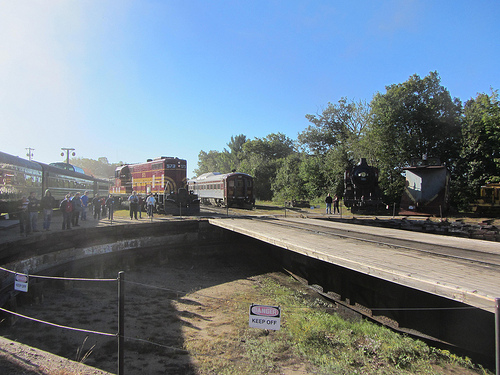Imagine this scene in a fantastical setting. Describe what changes you would see in the image. In a fantastical setting, this train station transforms into an enchanting, magical hub. The trains are no longer ordinary; one is a gleaming silver dragon train with scales that shimmer, while another is a floating crystal locomotive glowing with ethereal light. The platform is made of luminescent stones that shift colors gently underfoot. The trees in the background are the guardians of the forest, their leaves made of translucent gems and their branches whispering ancient secrets. In the sky, you see not only the sun but also floating islands with cascading waterfalls. Butterflies made of light flutter around, adding to the dreamlike quality of the scene. 